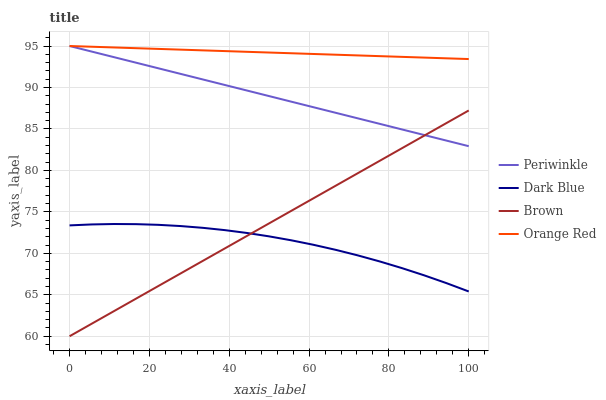Does Dark Blue have the minimum area under the curve?
Answer yes or no. Yes. Does Orange Red have the maximum area under the curve?
Answer yes or no. Yes. Does Periwinkle have the minimum area under the curve?
Answer yes or no. No. Does Periwinkle have the maximum area under the curve?
Answer yes or no. No. Is Periwinkle the smoothest?
Answer yes or no. Yes. Is Dark Blue the roughest?
Answer yes or no. Yes. Is Orange Red the smoothest?
Answer yes or no. No. Is Orange Red the roughest?
Answer yes or no. No. Does Brown have the lowest value?
Answer yes or no. Yes. Does Periwinkle have the lowest value?
Answer yes or no. No. Does Orange Red have the highest value?
Answer yes or no. Yes. Does Brown have the highest value?
Answer yes or no. No. Is Dark Blue less than Orange Red?
Answer yes or no. Yes. Is Periwinkle greater than Dark Blue?
Answer yes or no. Yes. Does Brown intersect Dark Blue?
Answer yes or no. Yes. Is Brown less than Dark Blue?
Answer yes or no. No. Is Brown greater than Dark Blue?
Answer yes or no. No. Does Dark Blue intersect Orange Red?
Answer yes or no. No. 